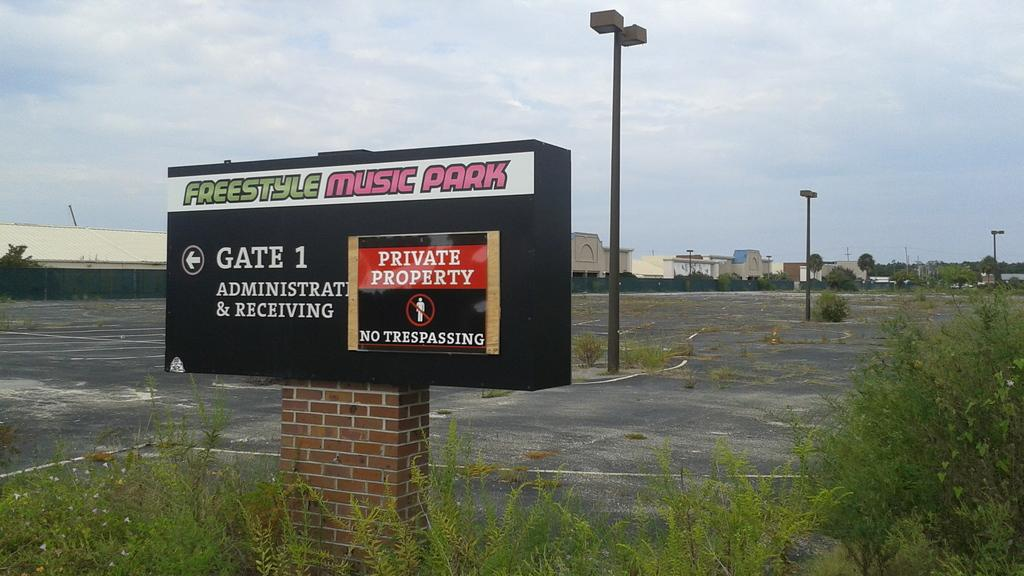<image>
Write a terse but informative summary of the picture. a sign for freestyle music park shows where gate 1 is 